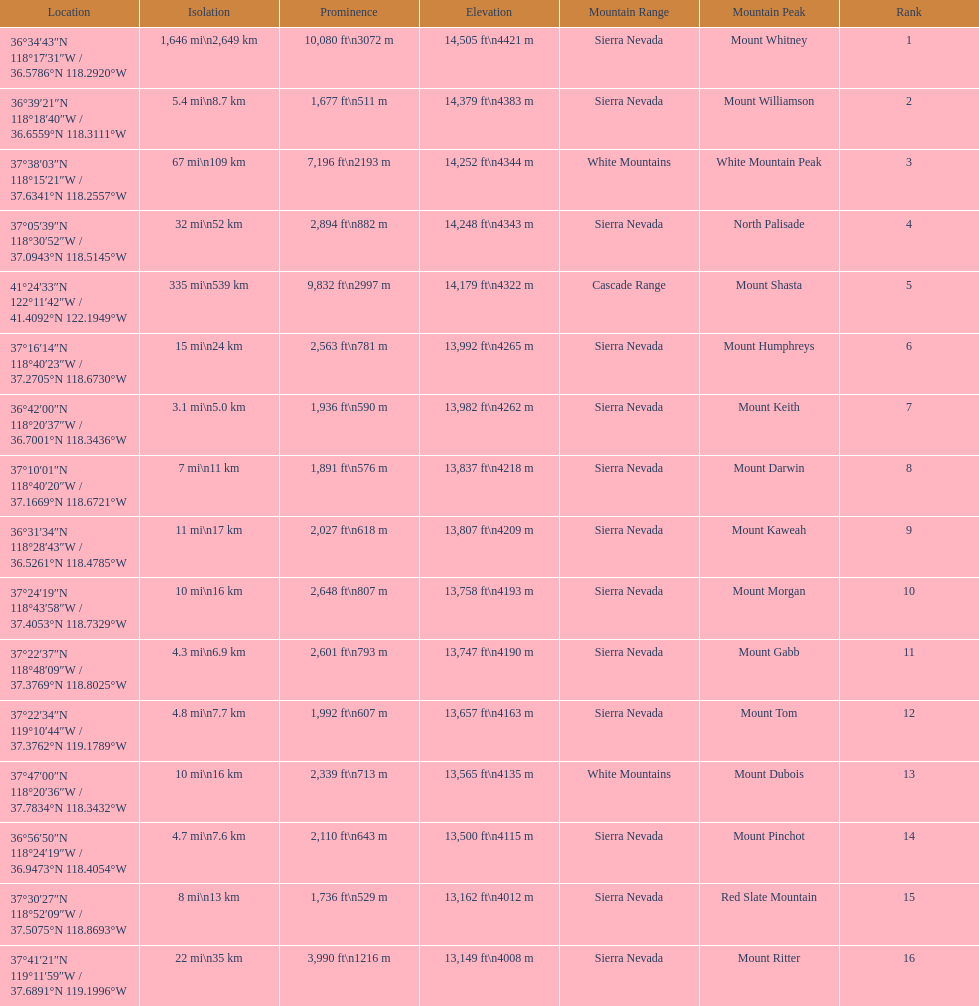Which mountain peak is the only mountain peak in the cascade range? Mount Shasta. 